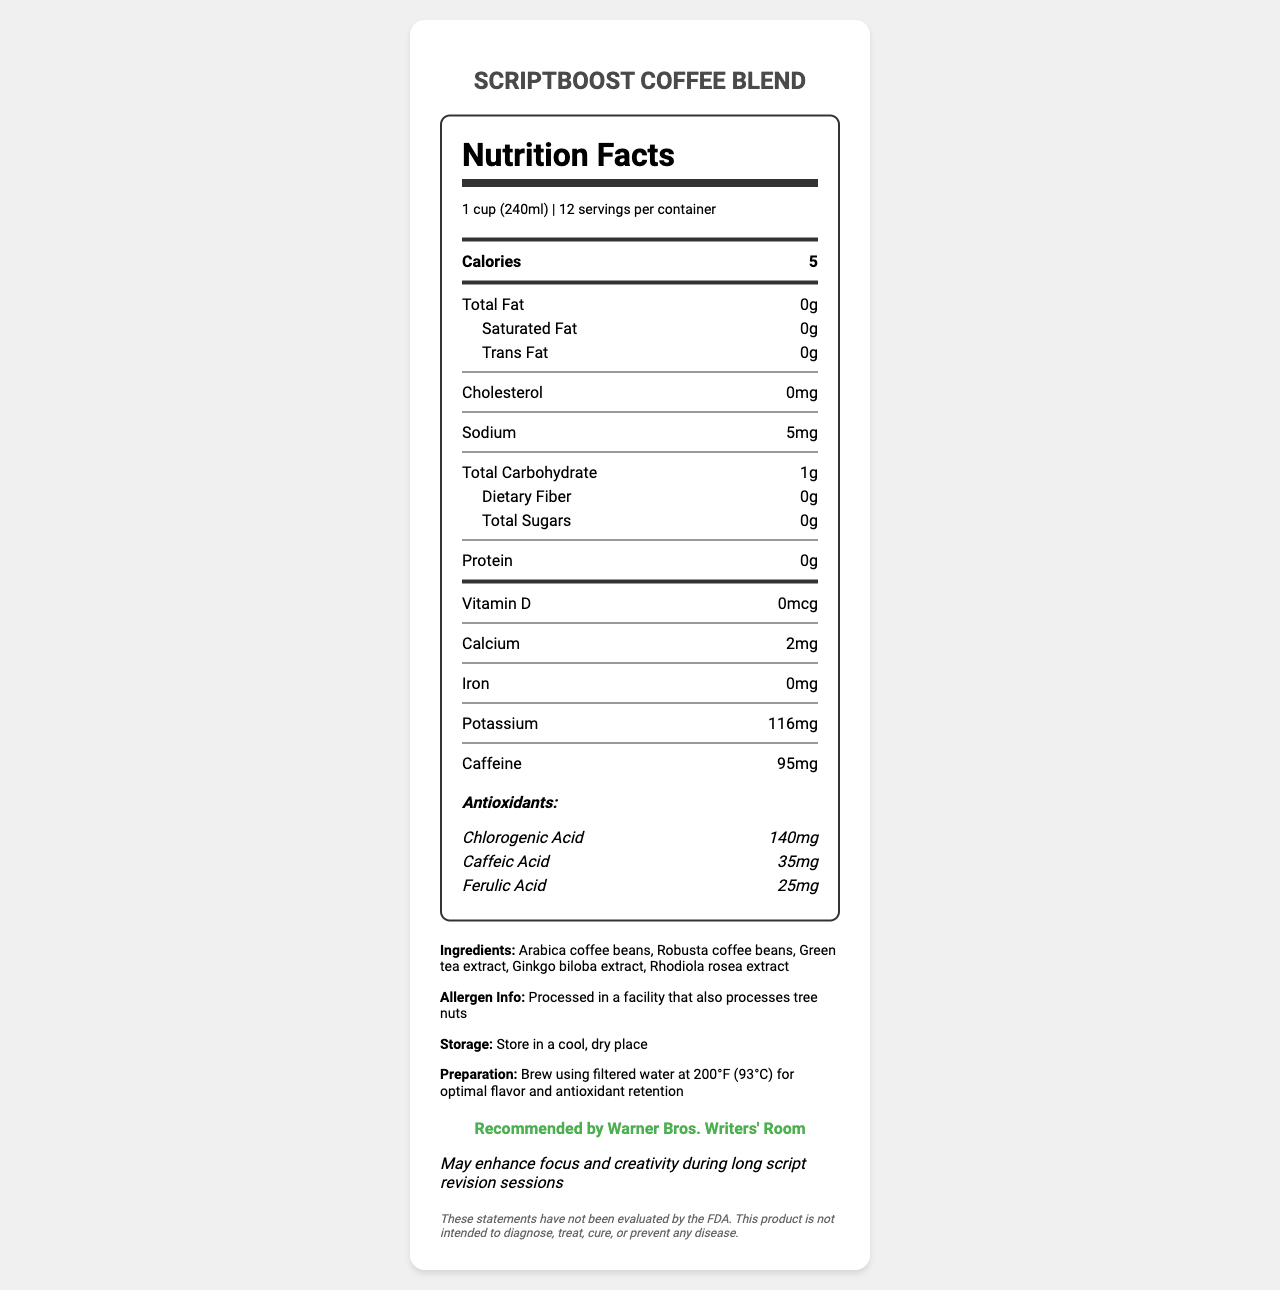what is the serving size of ScriptBoost Coffee Blend? The serving size is clearly stated at the top of the Nutrition Facts section.
Answer: 1 cup (240ml) how many calories are there per serving? The calories are listed near the top of the Nutrition Facts section.
Answer: 5 which ingredient is first listed in the ingredients list? The ingredients list shows "Arabica coffee beans" as the first item.
Answer: Arabica coffee beans what is the amount of potassium per serving? The amount of potassium is listed under the nutrient section with details.
Answer: 116mg are there any sugars in ScriptBoost Coffee Blend? The document states that the total sugars per serving are 0g.
Answer: No which extract is included to enhance creativity? A. Apple Extract B. Green Tea Extract C. Grape Seed Extract D. Turmeric Extract The ingredients list includes "Green tea extract", which is thought to enhance focus and creativity.
Answer: B how much caffeine does each serving contain? The document lists the caffeine content in the nutrient section.
Answer: 95mg does ScriptBoost Coffee Blend have any dietary fiber? The total dietary fiber is stated as 0g per serving.
Answer: No is the storage instruction to keep it in a warm place? The document advises storing it in a cool, dry place.
Answer: No how much chlorogenic acid is present in the coffee blend? The antioxidants section lists chlorogenic acid and its amount per serving.
Answer: 140mg were these statements evaluated by the FDA? The disclaimer at the bottom states that these statements have not been evaluated by the FDA.
Answer: No how many servings are there in one container of ScriptBoost Coffee Blend? The servings per container is listed at the top of the Nutrition Facts section.
Answer: 12 which scriptwriting studio recommends the product? The "studio_approved" section mentions it is recommended by Warner Bros. Writers' Room.
Answer: Warner Bros. Writers' Room what is the total cholesterol content in each serving? A. 0mg B. 5mg C. 10mg D. 20mg The cholesterol content is listed as 0mg per serving.
Answer: A how much Rhodiola rosea extract is included in the ingredients? The document lists "Rhodiola rosea extract" as an ingredient but does not specify the amount.
Answer: Cannot be determined what should be used to brew this coffee for optimal flavor? The preparation instruction specifies using filtered water at 200°F.
Answer: Filtered water at 200°F (93°C) what is the calorie content of ScriptBoost Coffee Blend? A. 50 B. 25 C. 10 D. 5 The calorie content is listed as 5 calories per serving.
Answer: D summarize the key details of ScriptBoost Coffee Blend from the Nutrition Facts Label The summary includes details about the product name, purpose, ingredients, key nutrient values, caffeine content, storage and preparation instructions, studio approval, and product claims.
Answer: ScriptBoost Coffee Blend is a specialty coffee designed to enhance creativity with ingredients such as Arabica and Robusta coffee beans and various extracts. It contains 5 calories per serving (240ml) with negligible fats, sugars, and proteins, but it offers 116mg of potassium and 95mg of caffeine. The coffee blend includes antioxidants like chlorogenic acid, caffeic acid, and ferulic acid. The product is studio-approved by Warner Bros. Writers' Room and claims to boost focus and creativity during script revisions. It should be brewed with filtered water at 200°F and stored in a cool, dry place. 